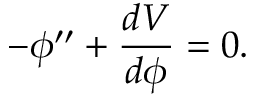Convert formula to latex. <formula><loc_0><loc_0><loc_500><loc_500>- \phi ^ { \prime \prime } + \frac { d V } { d \phi } = 0 .</formula> 